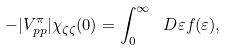<formula> <loc_0><loc_0><loc_500><loc_500>- | V _ { p p } ^ { \pi } | \chi _ { \zeta \zeta } ( 0 ) = \int _ { 0 } ^ { \infty } \ D \varepsilon f ( \varepsilon ) ,</formula> 